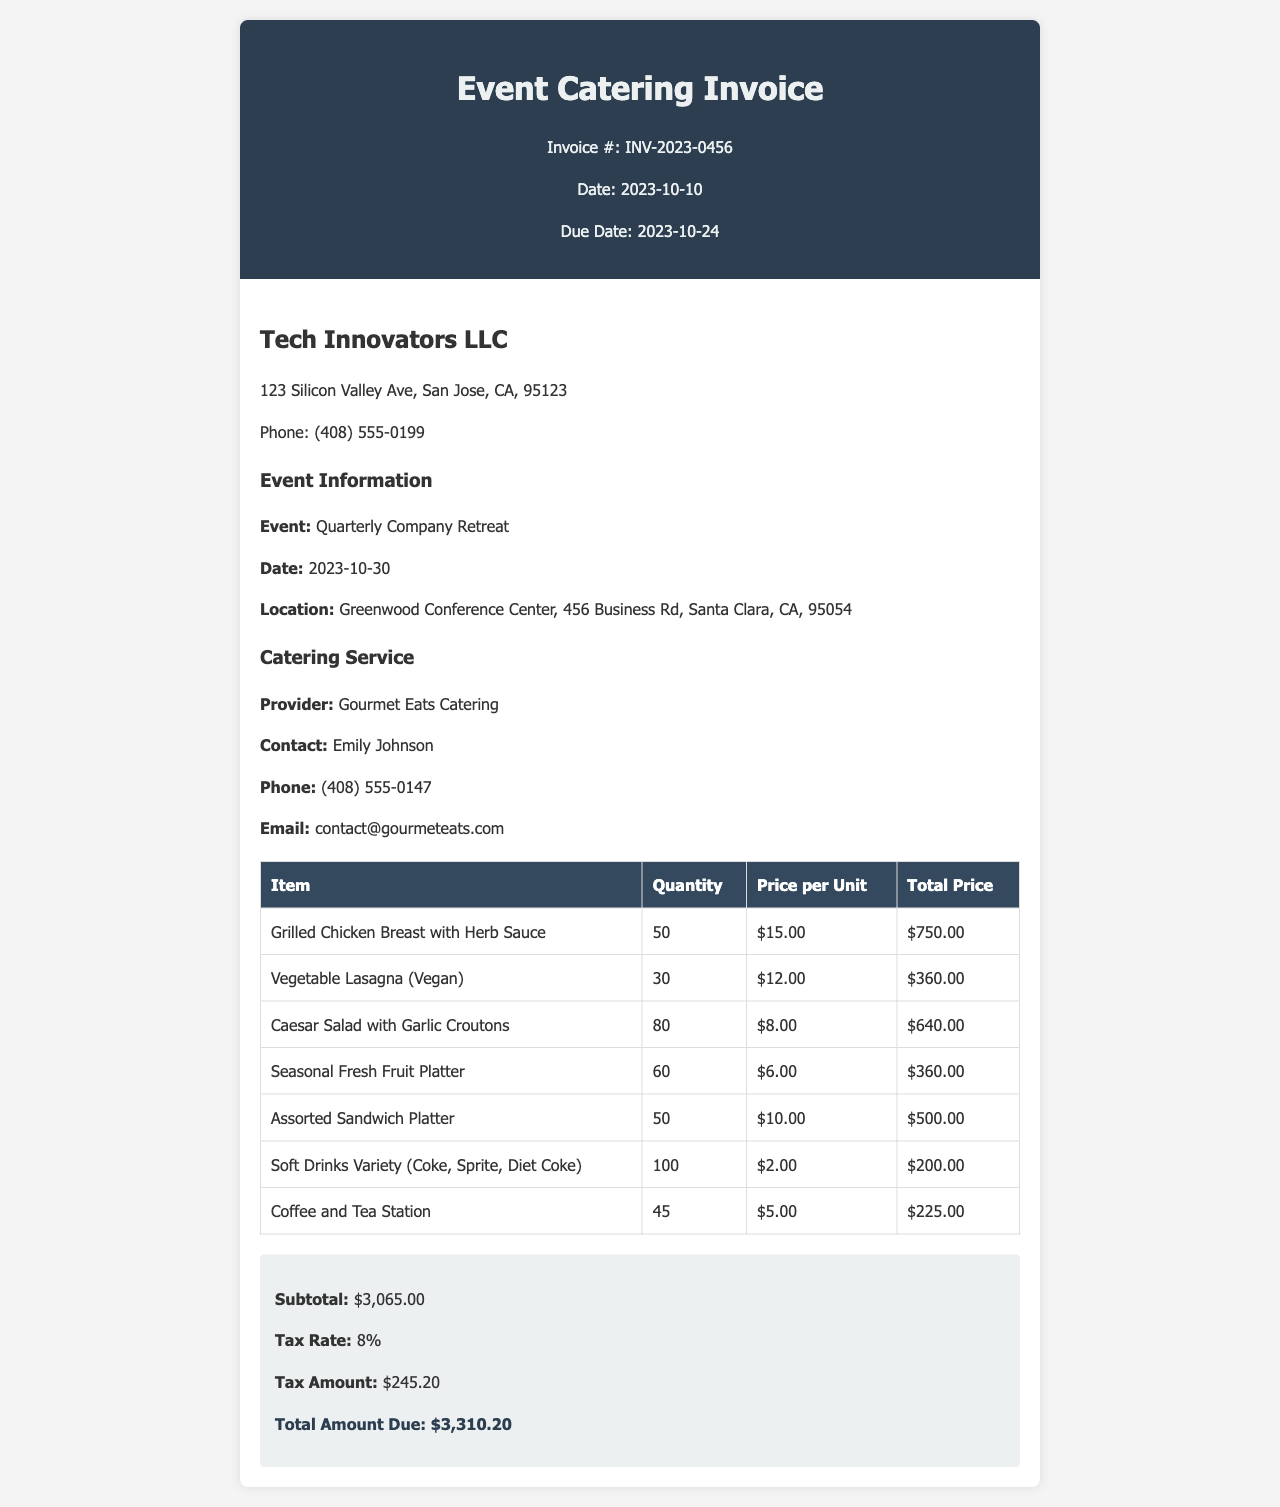What is the invoice number? The invoice number is displayed prominently in the header of the document.
Answer: INV-2023-0456 What is the due date for the invoice? The due date is provided in the header section of the document.
Answer: 2023-10-24 Who is the catering service provider? The provider's name is listed under the catering service section.
Answer: Gourmet Eats Catering What is the total amount due? The total amount due is calculated and presented at the end of the invoice.
Answer: $3,310.20 How many Grilled Chicken Breasts were ordered? The quantity ordered for Grilled Chicken Breast is specified in the itemized list.
Answer: 50 What is the tax rate applied in the invoice? The tax rate is mentioned in the total section of the invoice.
Answer: 8% What is the quantity of Soft Drinks Variety ordered? The quantity of Soft Drinks Variety is mentioned within the itemized list of catering items.
Answer: 100 How much does the Coffee and Tea Station cost per unit? The cost per unit for Coffee and Tea Station is shown in the itemized table.
Answer: $5.00 Which item had the highest total price? The total prices are listed in the itemized table, comparing them reveals which item is the highest.
Answer: Grilled Chicken Breast with Herb Sauce 